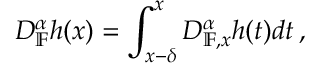<formula> <loc_0><loc_0><loc_500><loc_500>D _ { \mathbb { F } } ^ { \alpha } h ( x ) = \int _ { x - \delta } ^ { x } D _ { \mathbb { F } , x } ^ { \alpha } h ( t ) d t \, ,</formula> 